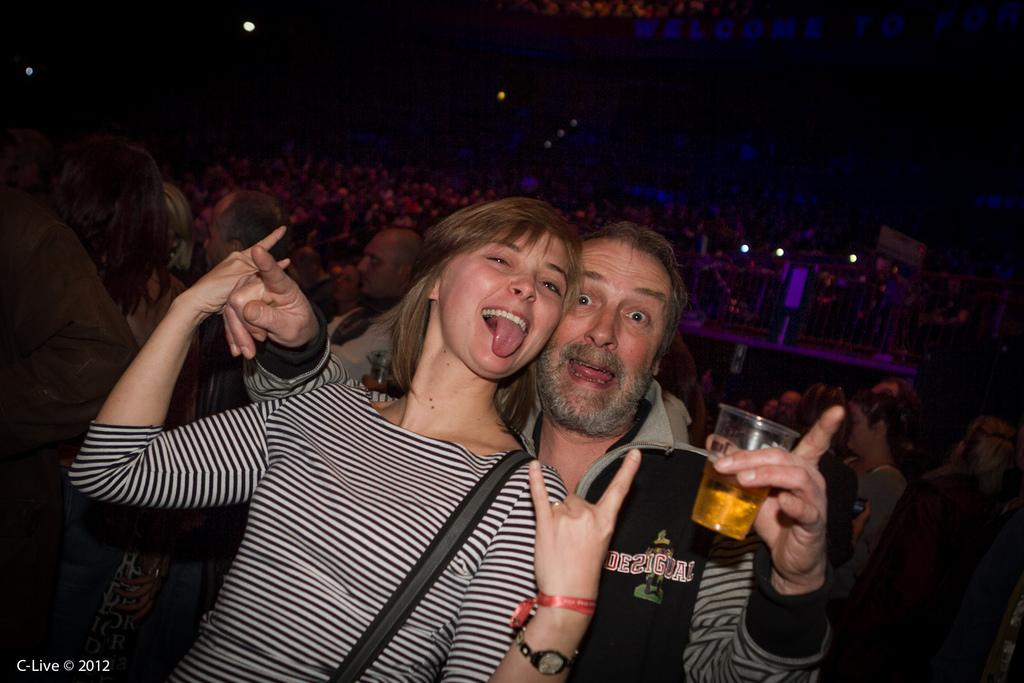How many people are in the image? There are people in the image, but the exact number is not specified. Can you describe the positions of the people in the image? Some people are seated, while others are standing. Who are the people standing in front? There is a man and a woman standing in front. What is the man holding in his hand? The man is holding a glass of beer in his hand. What type of powder is being used by the woman in the image? There is no mention of powder or any woman using powder in the image. 